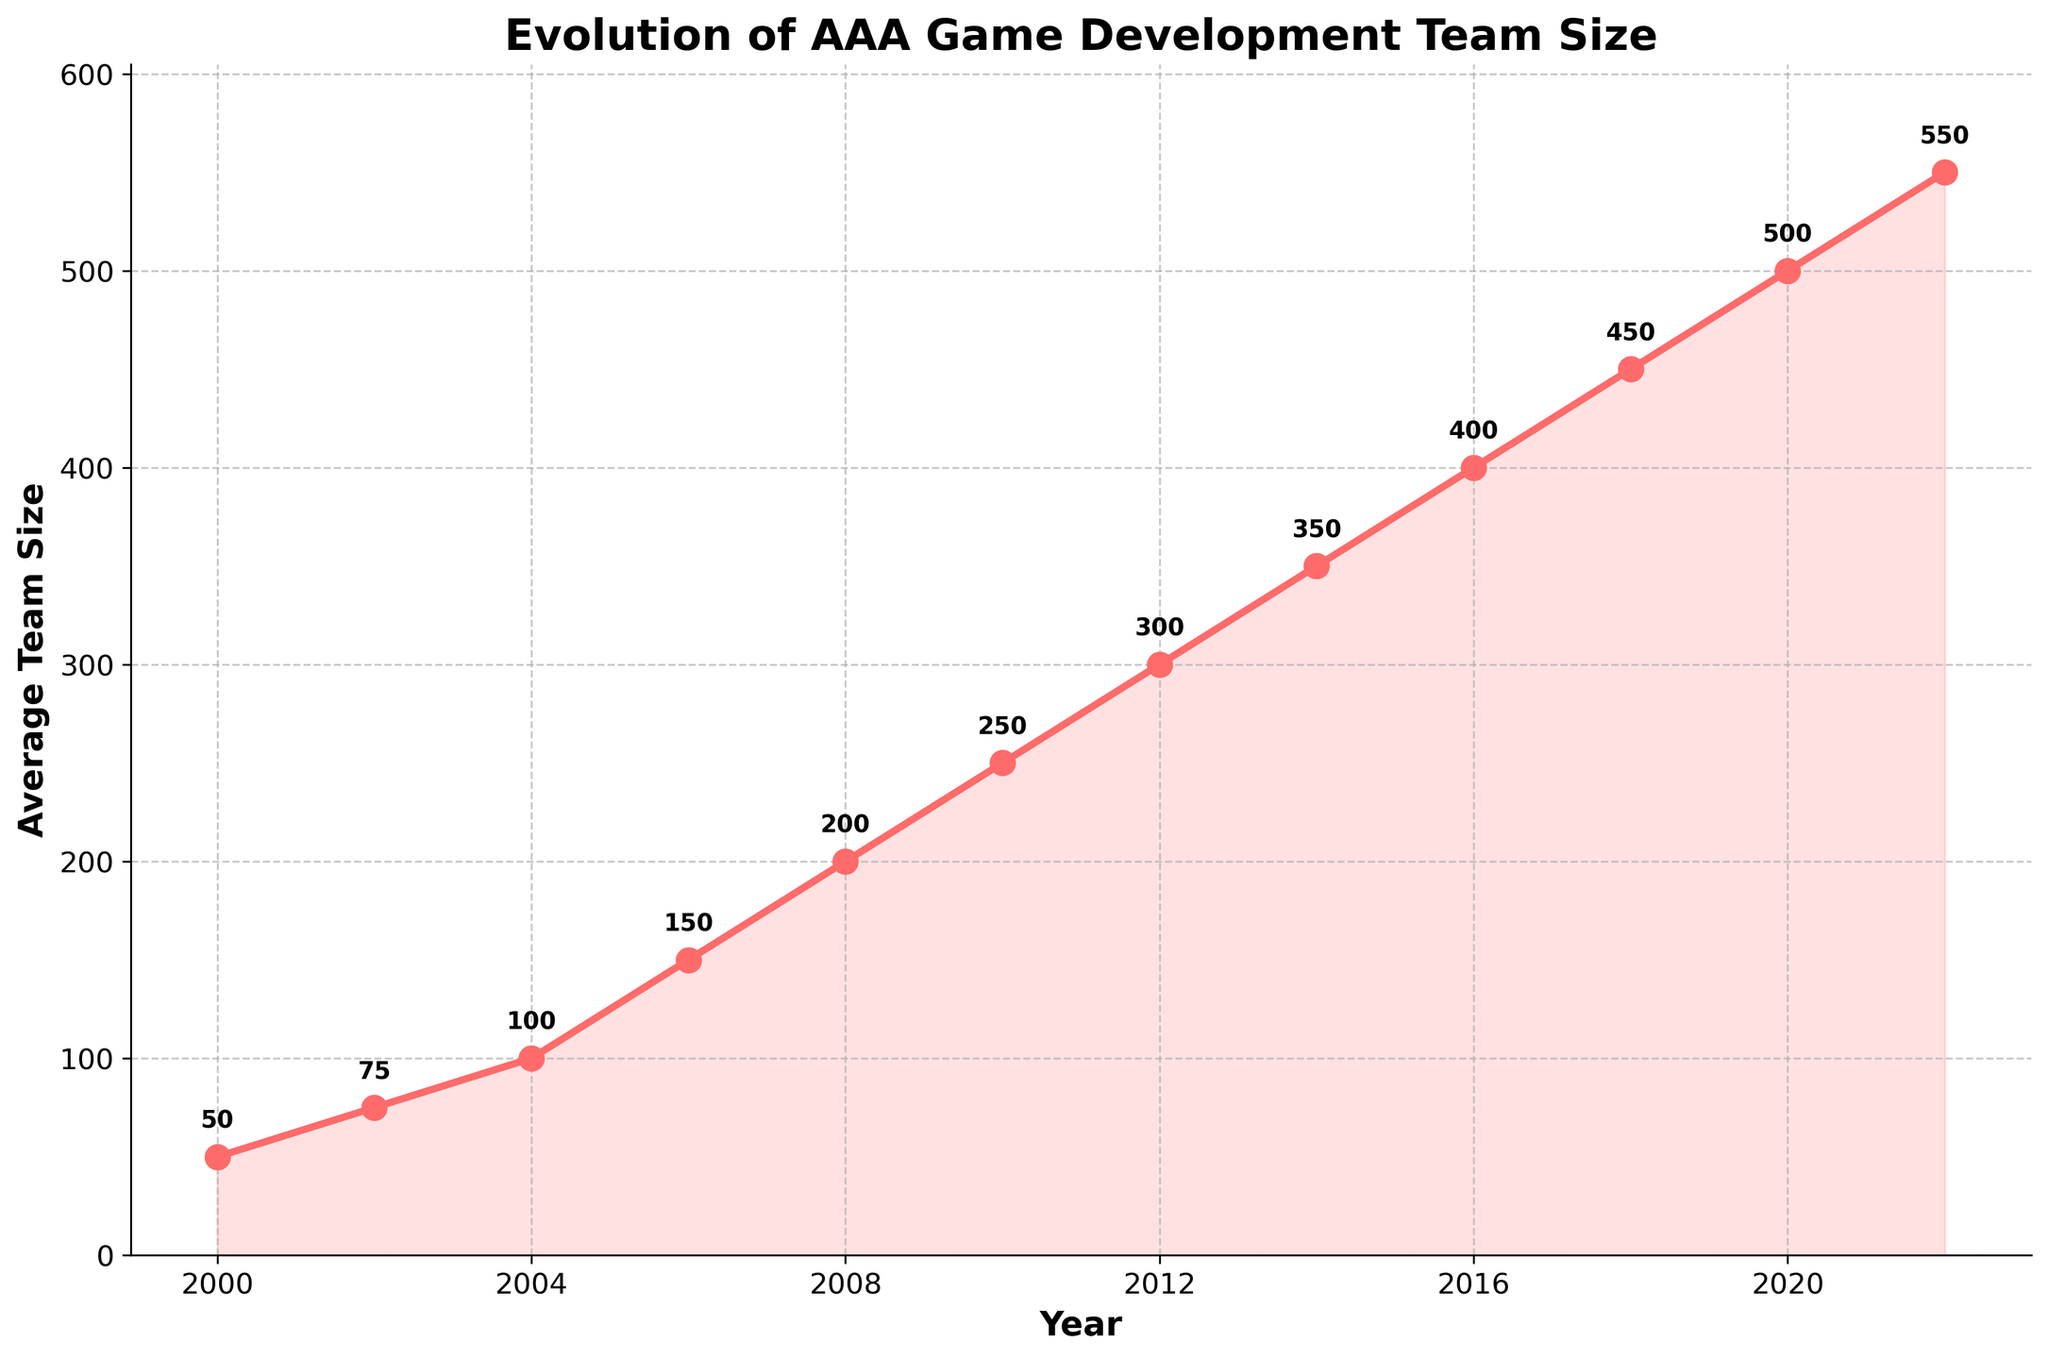What year did the average development team size reach 300? Look at the line chart and identify the year corresponding to the team size of 300.
Answer: 2012 How much did the average team size increase from 2008 to 2010? Subtract the average team size in 2008 (200) from the average team size in 2010 (250).
Answer: 50 Which year experienced the highest average team size, and what was that size? Identify the highest point on the line chart and note the corresponding year and team size.
Answer: 2022, 550 Between which two consecutive years was the increase in average team size the greatest, and what was the increase? Calculate the differences in team sizes between consecutive years and find the greatest increase. From 2004 to 2006, the increase is 50 (150-100). Other years have smaller or equal increases.
Answer: 2004 to 2006, 50 How long did it take for the average team size to double from its 2000 size? The team size in 2000 is 50. Look for the year when the team size reached 100, which is 2004. Subtract 2000 from 2004.
Answer: 4 years Was there any year when the average team size decreased compared to the previous year? Check the line chart to see if there is any downward slope. There is none, all years show an increase.
Answer: No How much did the average team size increase from 2000 to 2022? Subtract the average team size in 2000 (50) from the average team size in 2022 (550).
Answer: 500 What is the average team size over the entire period from 2000 to 2022? Sum up the team sizes for all the years and divide by the number of years. The sum is 50 + 75 + 100 + 150 + 200 + 250 + 300 + 350 + 400 + 450 + 500 + 550 = 3375, and there are 12 years. 3375 / 12 = 281.25.
Answer: 281.25 Which two years have the smallest change in average team size, and what is the difference? Calculate the differences in team sizes between consecutive years and find the smallest change. The smallest change is from 2018 to 2020, with an increase of 50 (500-450).
Answer: 2018 to 2020, 50 What pattern do you observe in the growth of the average team size over time? Describe the overall trend shown in the chart. The chart shows a steady increase in the average team size almost every year, with no declines.
Answer: Steady increase 